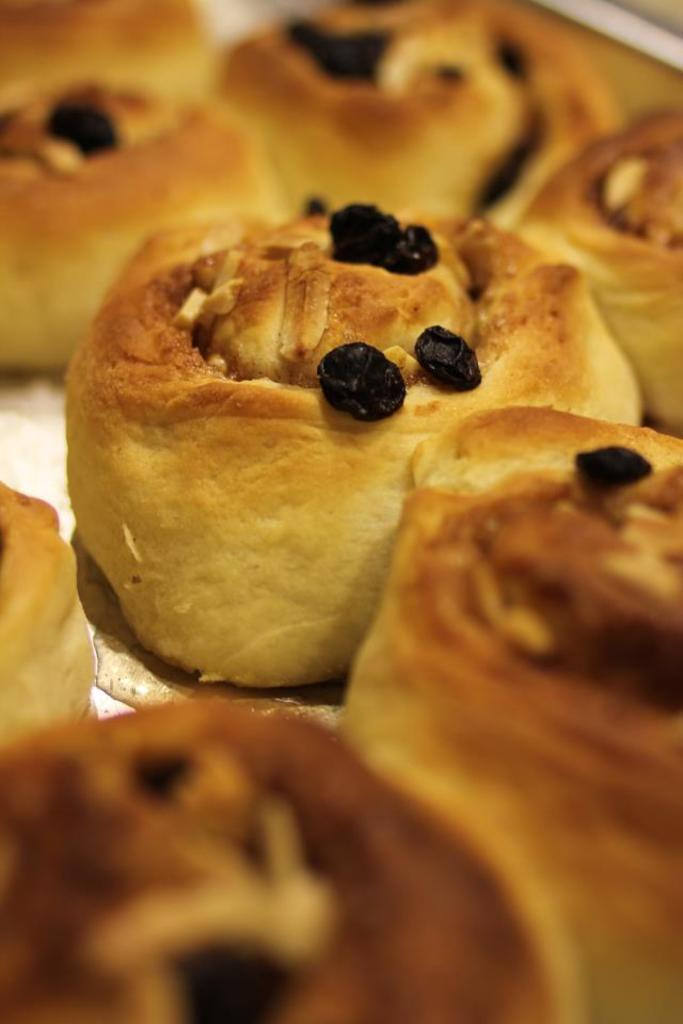What type of food items can be seen in the image? There are baked food items in the image. Can you read the note that the bee is holding next to the baked food items in the image? There is no bee or note present in the image; it only features baked food items. 